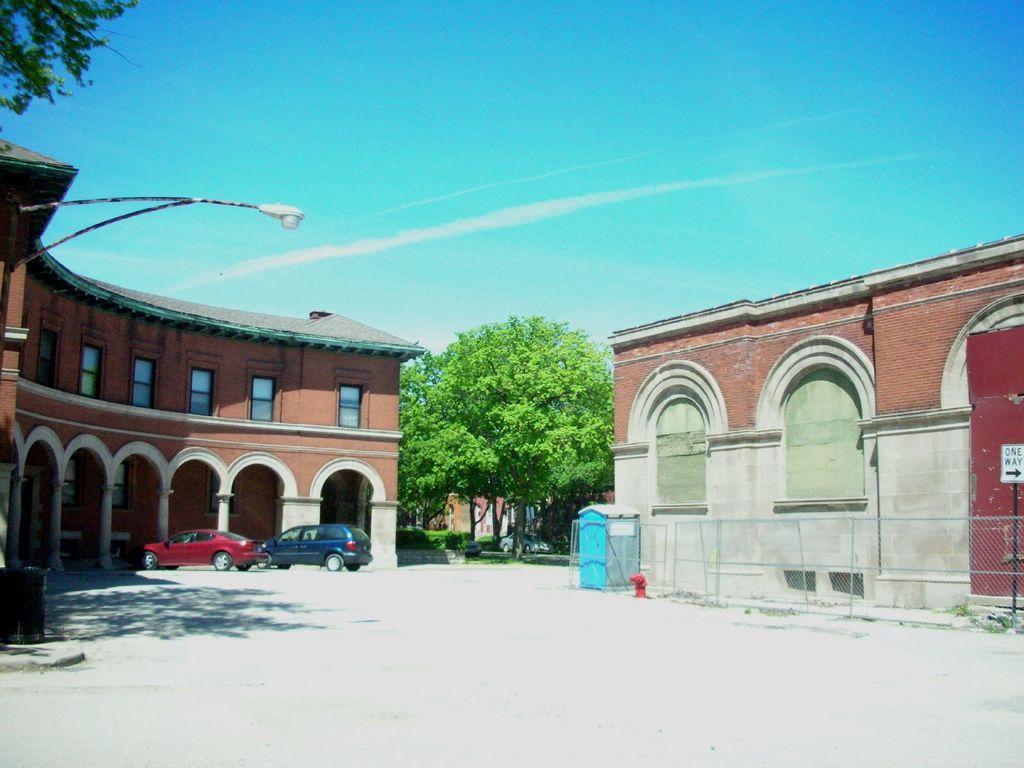Describe this image in one or two sentences. There is a building in the left corner and there are two cars in front of it and there is another building in the right corner and there are trees in the background. 